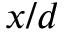Convert formula to latex. <formula><loc_0><loc_0><loc_500><loc_500>x / d</formula> 